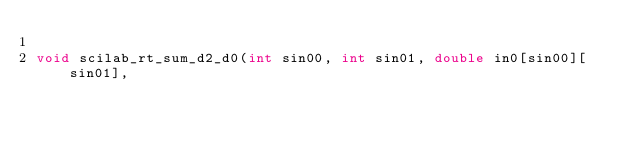<code> <loc_0><loc_0><loc_500><loc_500><_C_>
void scilab_rt_sum_d2_d0(int sin00, int sin01, double in0[sin00][sin01],</code> 